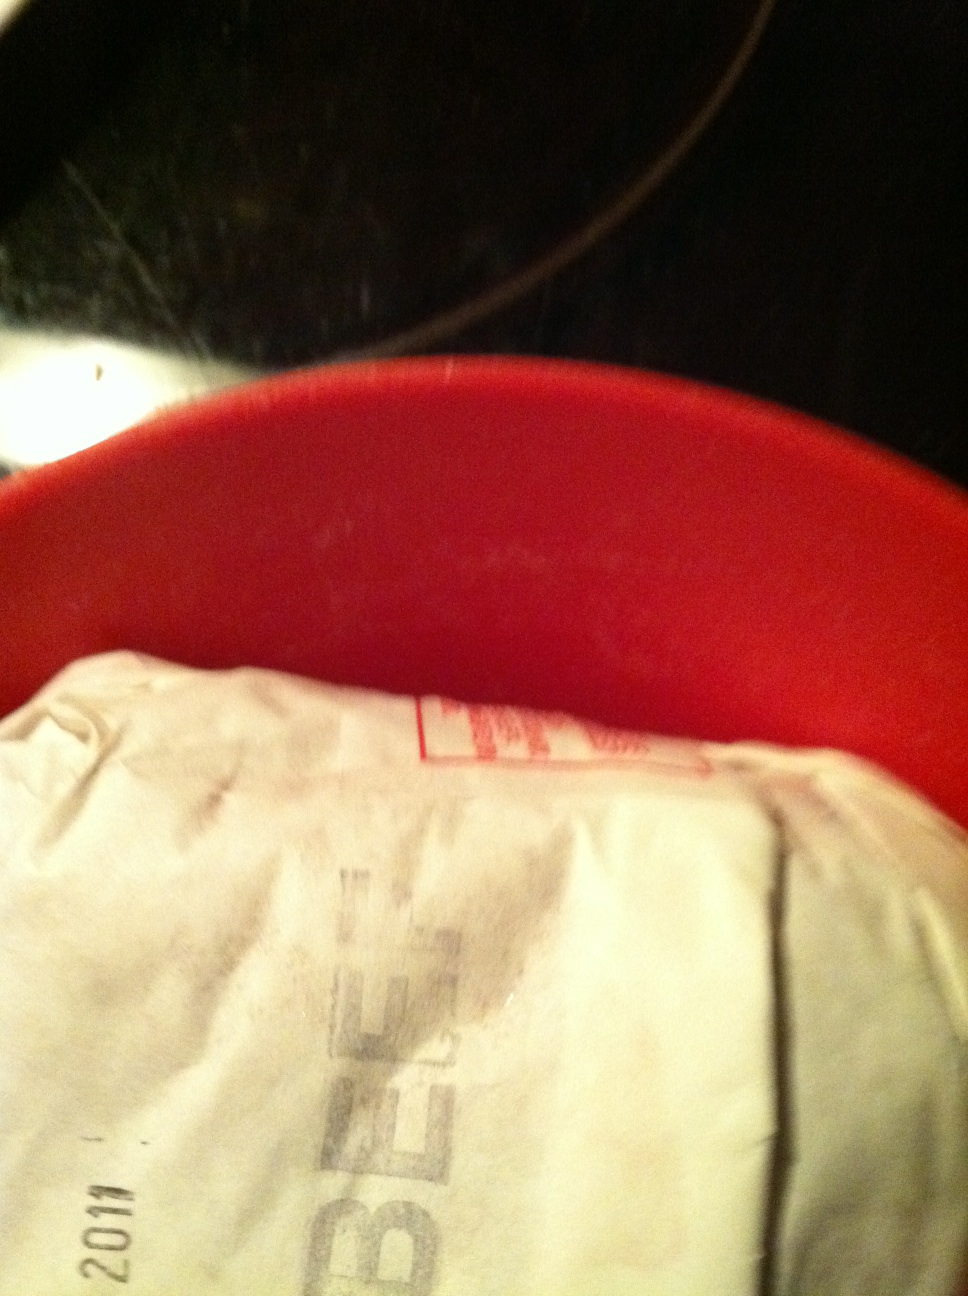What are some unique dishes that can be made with beef? Beef is an incredibly versatile ingredient and can be used in a myriad of unique dishes. Here are some examples:

1. **Beef Wellington:** A luxurious dish featuring beef tenderloin coated with pâté and duxelles, then wrapped in puff pastry and baked to perfection.
2. **Pho:** A traditional Vietnamese soup consisting of broth, rice noodles, herbs, and thinly sliced beef.
3. **Karé Raisu (Japanese Curry Rice):** A popular Japanese dish with a thick, savory curry sauce poured over rice, containing beef and assorted vegetables.
4. **Beef Carpaccio:** A dish of thinly sliced raw beef, typically served with a bit of lemon juice, olive oil, and parmesan cheese.
5. **Bulgogi:** A Korean dish consisting of marinated beef grilled or stir-fried, often served with vegetables and rice.  Imagine this beef is part of a grand feast in a futuristic setting. What kind of story would unfold? In a distant future, where humanity has colonized multiple planets, this humble package of beef plays a central role in a grand feast that unites diverse alien species with Earth’s inhabitants. The beef is marinated with spices sourced from different corners of the galaxy, infused with herbs that glow with bioluminescence, creating a visually stunning centerpiece for the feast. The dish symbolizes unity and cooperation among interstellar beings, breaking culinary barriers and celebrating the blending of cultures. It is served in an immense hall aboard a spacecraft, where the walls are transparent, providing a mesmerizing view of the stars. The scent of the marinated beef wafts through the air, enticing all guests, regardless of their origin. What are some realistic uses of this beef in a modern kitchen? In a modern kitchen, this beef could be used in various everyday dishes, such as:

- Grilled steaks for a family barbecue.
- Homemade hamburgers for a weekend treat.
- Beef stroganoff, combining the beef with mushrooms and a creamy sauce, served over egg noodles for a comforting meal. 
- Tacos, seasoned with a blend of spices and served with fresh toppings like lettuce, tomato, and cheese. 
- Slow-cooked pot roast with vegetables, perfect for a hearty Sunday dinner. Can you describe in detail how to prepare a perfect grilled steak using this beef? Absolutely! Here's a detailed guide to grilling a perfect steak:

Ingredients:

- Beef steak (ribeye, sirloin, or your choice), about 1-inch thick
- Salt
- Freshly ground black pepper
- Olive oil
- Butter (optional)
- Fresh herbs (such as thyme or rosemary, optional)
- Garlic cloves (optional)

Instructions:

1. **Prepare the Steak:** Take the beef steak out of the refrigerator and let it come to room temperature for about 30 minutes. This ensures even cooking.

2. **Seasoning:** Pat the steak dry with paper towels to remove excess moisture. Generously season both sides with salt and freshly ground black pepper. You can also drizzle a bit of olive oil on the steak and rub it in.

3. **Preheat the Grill:** Preheat your grill to high heat, around 450-500°F. If using a charcoal grill, make sure the coals are evenly distributed and glowing red before placing the steak on the grill.

4. **Cooking the Steak:** Place the steak on the hot grill. For medium-rare, grill the steak for about 4-5 minutes on each side. Avoid moving the steak too much to get those perfect grill marks.

5. **Butter Basting (Optional):** For added flavor, you can baste the steak with butter. When you flip the steak, add a tablespoon of butter, a sprig of fresh herbs, and a couple of crushed garlic cloves on top. As the butter melts, it will infuse the steak with rich flavors.

6. **Check for Doneness:** Use a meat thermometer to check the internal temperature. For medium-rare, look for 130-135°F. For medium, 135-145°F. Remember that the steak will continue to cook a bit after you take it off the grill.

7. **Resting:** Once cooked to your desired doneness, remove the steak from the grill and let it rest on a cutting board for about 5-10 minutes. This allows the juices to redistribute throughout the meat, keeping it tender and flavorful.

8. **Serving:** Slice the steak against the grain and serve immediately. Enjoy your perfectly grilled steak with your favorite sides!

Tips:
- If you prefer crosshatch grill marks, rotate the steak 90 degrees halfway through cooking on each side.
- Letting the steak rest is crucial for a juicy result, so don’t skip this step!
- Experiment with different seasonings and marinades to find your perfect flavor combination. 